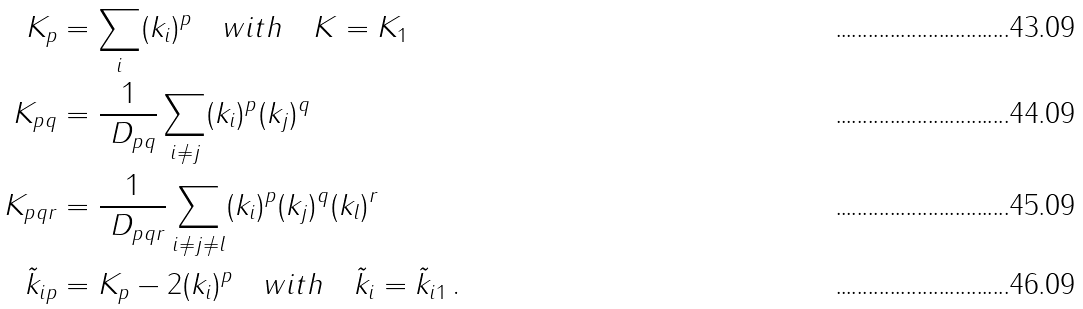<formula> <loc_0><loc_0><loc_500><loc_500>K _ { p } & = \sum _ { i } ( k _ { i } ) ^ { p } \quad w i t h \quad K = K _ { 1 } \\ K _ { p q } & = \frac { 1 } { \ D _ { p q } } \sum _ { i \not = j } ( k _ { i } ) ^ { p } ( k _ { j } ) ^ { q } \\ K _ { p q r } & = \frac { 1 } { \ D _ { p q r } } \sum _ { i \not = j \not = l } ( k _ { i } ) ^ { p } ( k _ { j } ) ^ { q } ( k _ { l } ) ^ { r } \\ \tilde { k } _ { i p } & = K _ { p } - 2 ( k _ { i } ) ^ { p } \quad w i t h \quad \tilde { k } _ { i } = \tilde { k } _ { i 1 } \, .</formula> 